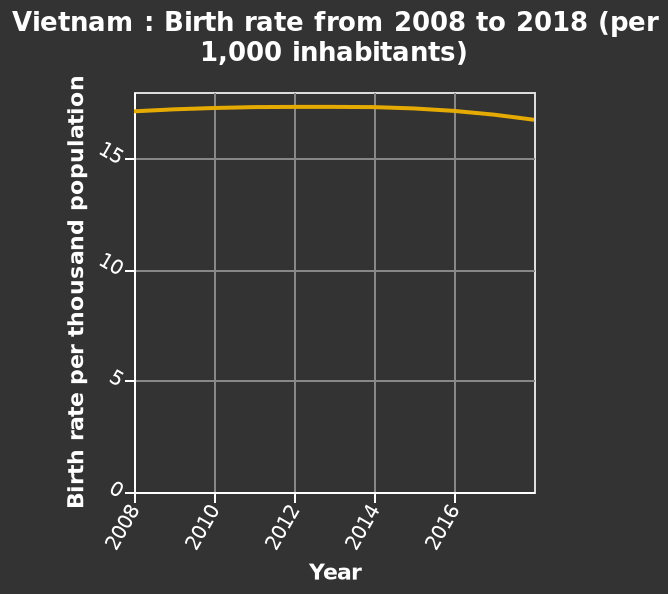<image>
What is the unit of measurement for the birth rate on the line plot? Birth rate per 1,000 inhabitants What is the range of the y-axis on the line plot? 0 to 15 How is the birth rate of Vietnam measured? The birth rate of Vietnam is measured per 1000 inhabitants. 